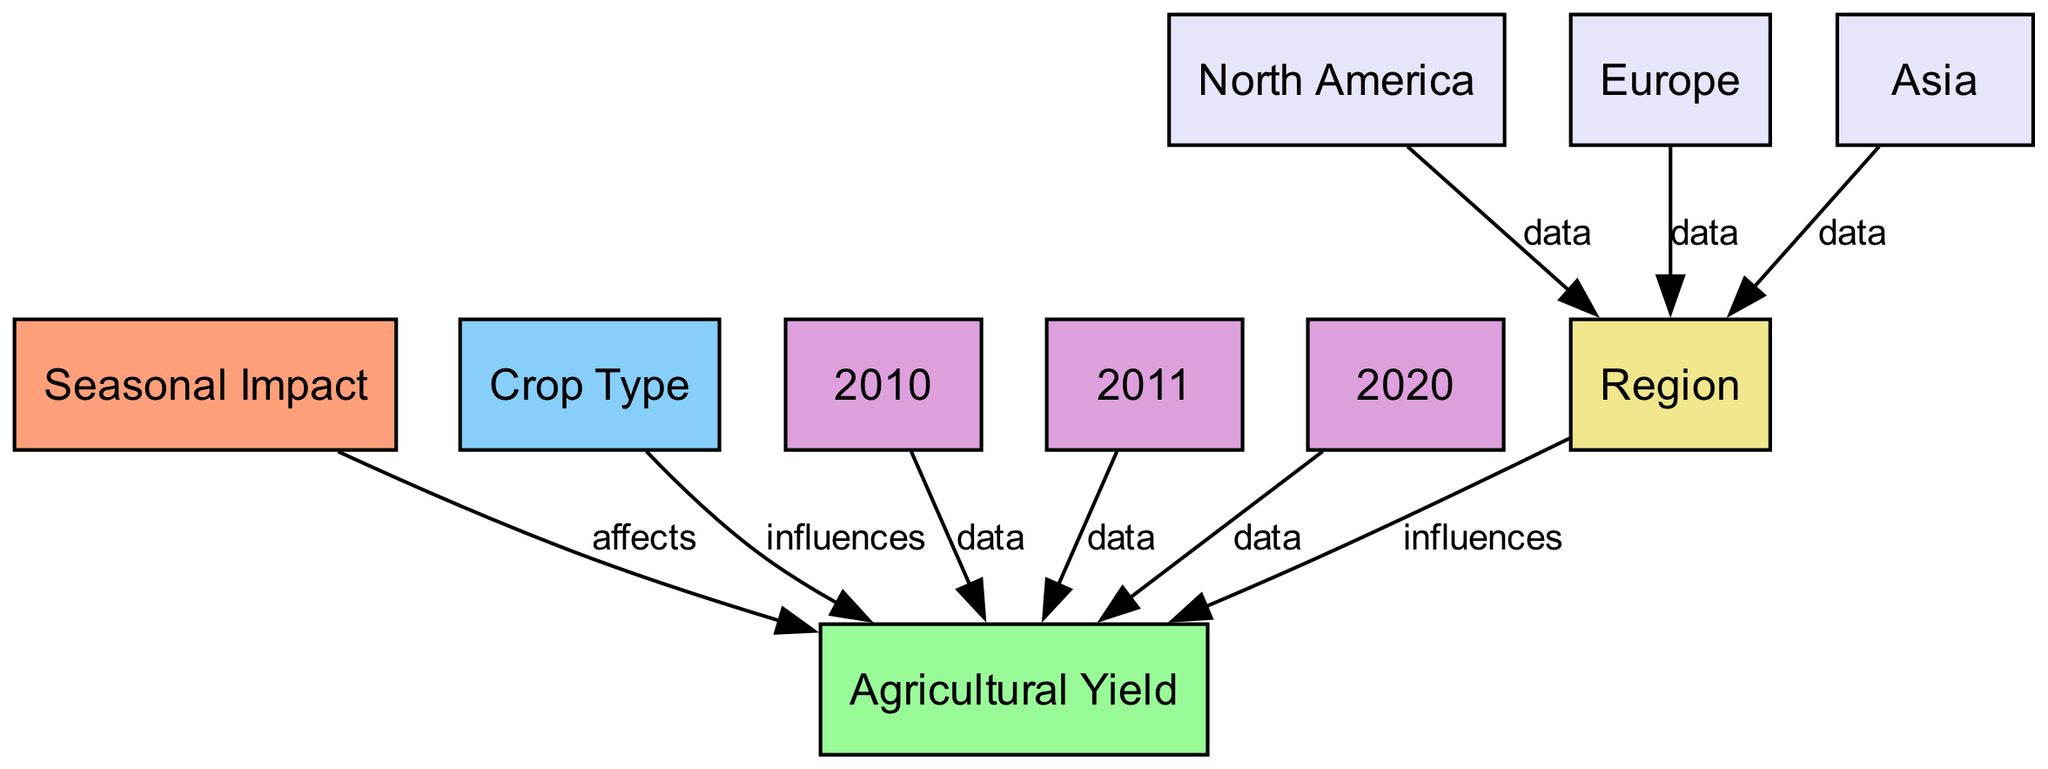What is affected by seasonal impact? The diagram shows a directed edge from "Seasonal Impact" to "Agricultural Yield" with the label "affects", indicating that seasonal impact has a direct influence on agricultural yield.
Answer: Agricultural Yield How many years of data are represented in the diagram? The diagram includes nodes for three different years: 2010, 2011, and 2020, which indicates that there are three years of data depicted in the diagram.
Answer: 3 Which crop type influences agricultural yield? The diagram illustrates a directed edge from "Crop Type" to "Agricultural Yield" labeled "influences", showing that crop type has an influence on agricultural yield.
Answer: Crop Type Which region is represented in the diagram? The diagram features nodes for three regions: North America, Europe, and Asia. Therefore, the regions represented are the ones indicated in these nodes.
Answer: North America, Europe, Asia What influences agricultural yield aside from crop type? The diagram demonstrates that "Region" also influences "Agricultural Yield", as indicated by the edge labeled "influences" from "Region" to "Agricultural Yield".
Answer: Region In which year was the most recent data collected? The most recent year represented in the diagram is 2020, as indicated by the node labeled "2020".
Answer: 2020 How does North America relate to region? The diagram shows a directed edge between "North America" and "Region" labeled "data", meaning that North America is a specific geographical data point under the broader category of region.
Answer: data How many edges are there in total? By counting the edges listed in the diagram, there are a total of 7 edges, showing relationships and influences between different nodes.
Answer: 7 Which crop type appears in the diagram? The diagram mentions "Crop Type" but does not specify particular types; however, it indicates that the crop type is a category under which various agricultural yields can be influenced.
Answer: Crop Type 